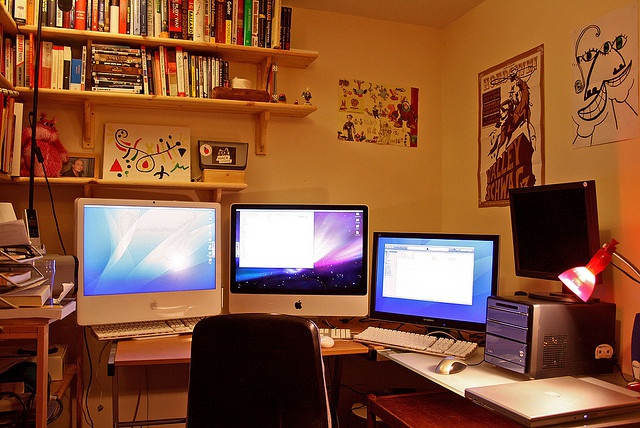Describe the objects in this image and their specific colors. I can see book in orange, maroon, brown, and black tones, tv in orange, white, tan, lightblue, and salmon tones, tv in orange, white, black, tan, and brown tones, chair in orange, black, maroon, brown, and tan tones, and tv in orange, white, blue, black, and lightblue tones in this image. 